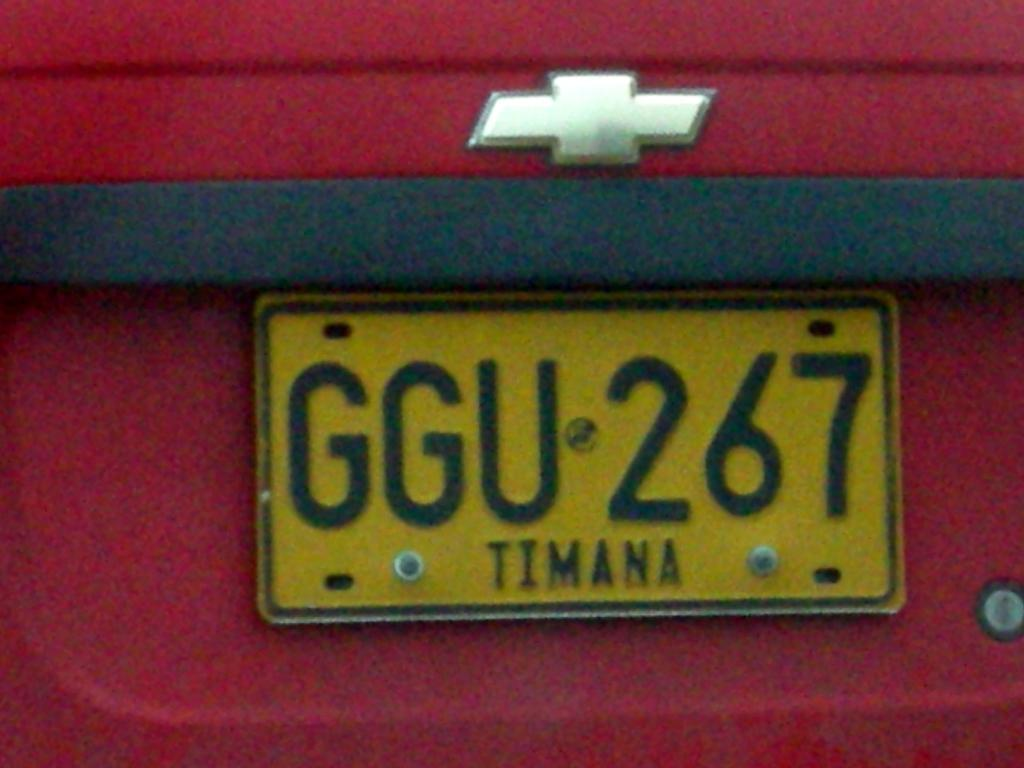<image>
Relay a brief, clear account of the picture shown. the letters GGU that are on a license plate 